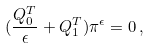<formula> <loc_0><loc_0><loc_500><loc_500>( \frac { Q _ { 0 } ^ { T } } { \epsilon } + Q _ { 1 } ^ { T } ) \pi ^ { \epsilon } = 0 \, ,</formula> 